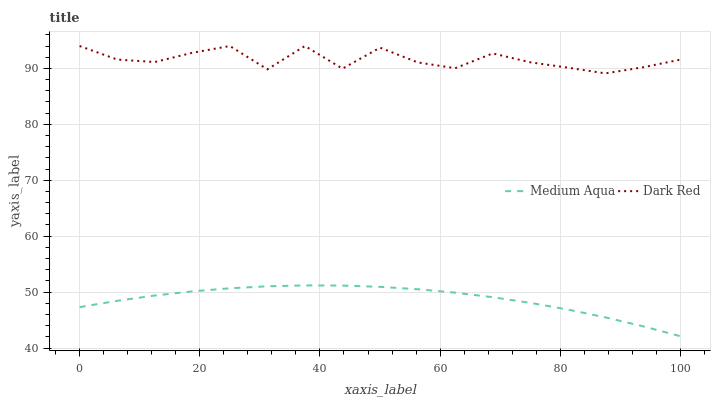Does Medium Aqua have the minimum area under the curve?
Answer yes or no. Yes. Does Dark Red have the maximum area under the curve?
Answer yes or no. Yes. Does Medium Aqua have the maximum area under the curve?
Answer yes or no. No. Is Medium Aqua the smoothest?
Answer yes or no. Yes. Is Dark Red the roughest?
Answer yes or no. Yes. Is Medium Aqua the roughest?
Answer yes or no. No. Does Medium Aqua have the lowest value?
Answer yes or no. Yes. Does Dark Red have the highest value?
Answer yes or no. Yes. Does Medium Aqua have the highest value?
Answer yes or no. No. Is Medium Aqua less than Dark Red?
Answer yes or no. Yes. Is Dark Red greater than Medium Aqua?
Answer yes or no. Yes. Does Medium Aqua intersect Dark Red?
Answer yes or no. No. 